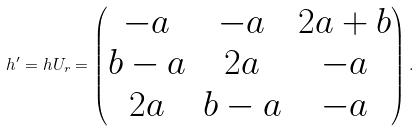<formula> <loc_0><loc_0><loc_500><loc_500>h ^ { \prime } = h U _ { r } = \begin{pmatrix} - a & - a & 2 a + b \\ b - a & 2 a & - a \\ 2 a & b - a & - a \end{pmatrix} .</formula> 